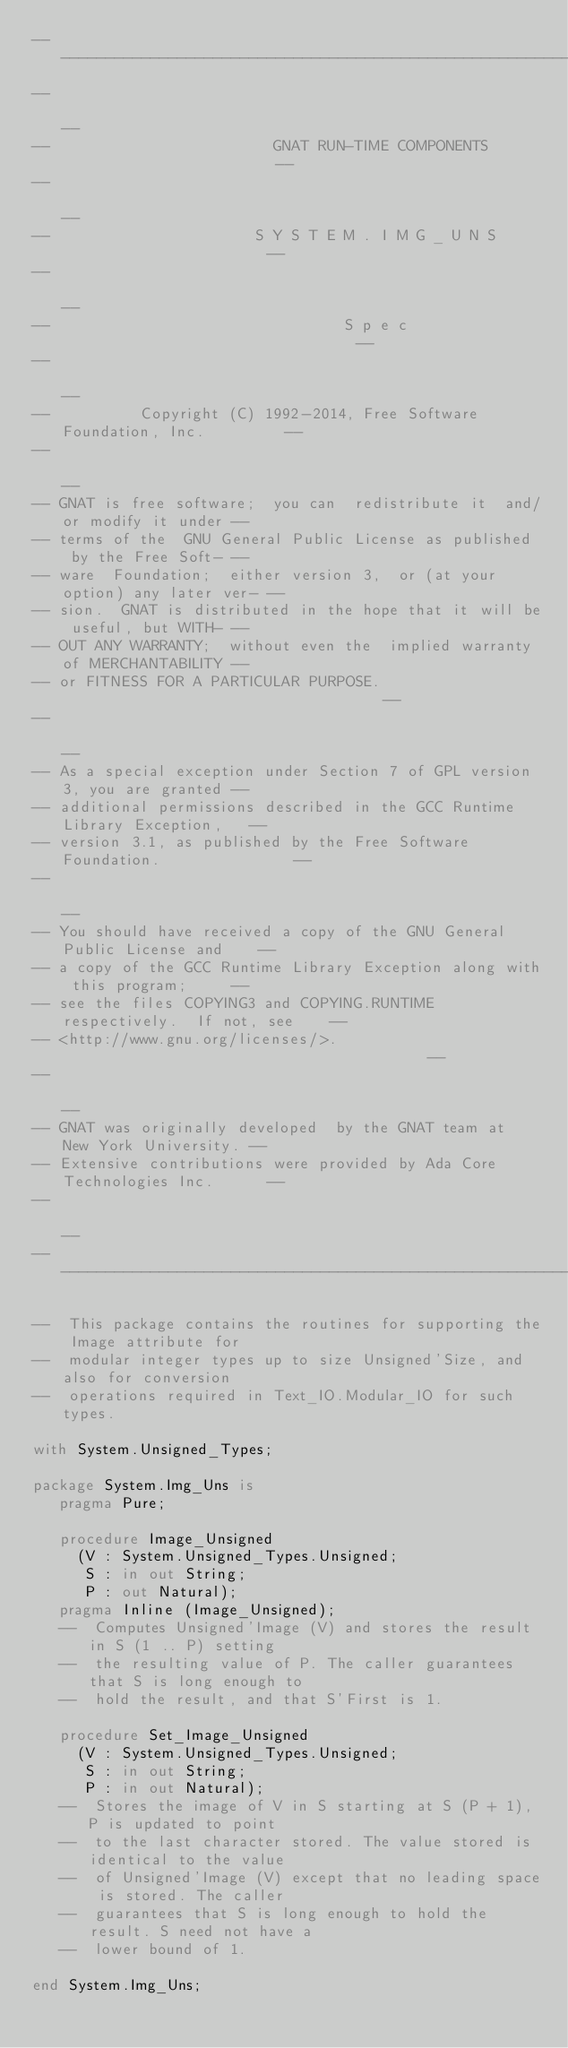Convert code to text. <code><loc_0><loc_0><loc_500><loc_500><_Ada_>------------------------------------------------------------------------------
--                                                                          --
--                         GNAT RUN-TIME COMPONENTS                         --
--                                                                          --
--                       S Y S T E M . I M G _ U N S                        --
--                                                                          --
--                                 S p e c                                  --
--                                                                          --
--          Copyright (C) 1992-2014, Free Software Foundation, Inc.         --
--                                                                          --
-- GNAT is free software;  you can  redistribute it  and/or modify it under --
-- terms of the  GNU General Public License as published  by the Free Soft- --
-- ware  Foundation;  either version 3,  or (at your option) any later ver- --
-- sion.  GNAT is distributed in the hope that it will be useful, but WITH- --
-- OUT ANY WARRANTY;  without even the  implied warranty of MERCHANTABILITY --
-- or FITNESS FOR A PARTICULAR PURPOSE.                                     --
--                                                                          --
-- As a special exception under Section 7 of GPL version 3, you are granted --
-- additional permissions described in the GCC Runtime Library Exception,   --
-- version 3.1, as published by the Free Software Foundation.               --
--                                                                          --
-- You should have received a copy of the GNU General Public License and    --
-- a copy of the GCC Runtime Library Exception along with this program;     --
-- see the files COPYING3 and COPYING.RUNTIME respectively.  If not, see    --
-- <http://www.gnu.org/licenses/>.                                          --
--                                                                          --
-- GNAT was originally developed  by the GNAT team at  New York University. --
-- Extensive contributions were provided by Ada Core Technologies Inc.      --
--                                                                          --
------------------------------------------------------------------------------

--  This package contains the routines for supporting the Image attribute for
--  modular integer types up to size Unsigned'Size, and also for conversion
--  operations required in Text_IO.Modular_IO for such types.

with System.Unsigned_Types;

package System.Img_Uns is
   pragma Pure;

   procedure Image_Unsigned
     (V : System.Unsigned_Types.Unsigned;
      S : in out String;
      P : out Natural);
   pragma Inline (Image_Unsigned);
   --  Computes Unsigned'Image (V) and stores the result in S (1 .. P) setting
   --  the resulting value of P. The caller guarantees that S is long enough to
   --  hold the result, and that S'First is 1.

   procedure Set_Image_Unsigned
     (V : System.Unsigned_Types.Unsigned;
      S : in out String;
      P : in out Natural);
   --  Stores the image of V in S starting at S (P + 1), P is updated to point
   --  to the last character stored. The value stored is identical to the value
   --  of Unsigned'Image (V) except that no leading space is stored. The caller
   --  guarantees that S is long enough to hold the result. S need not have a
   --  lower bound of 1.

end System.Img_Uns;
</code> 